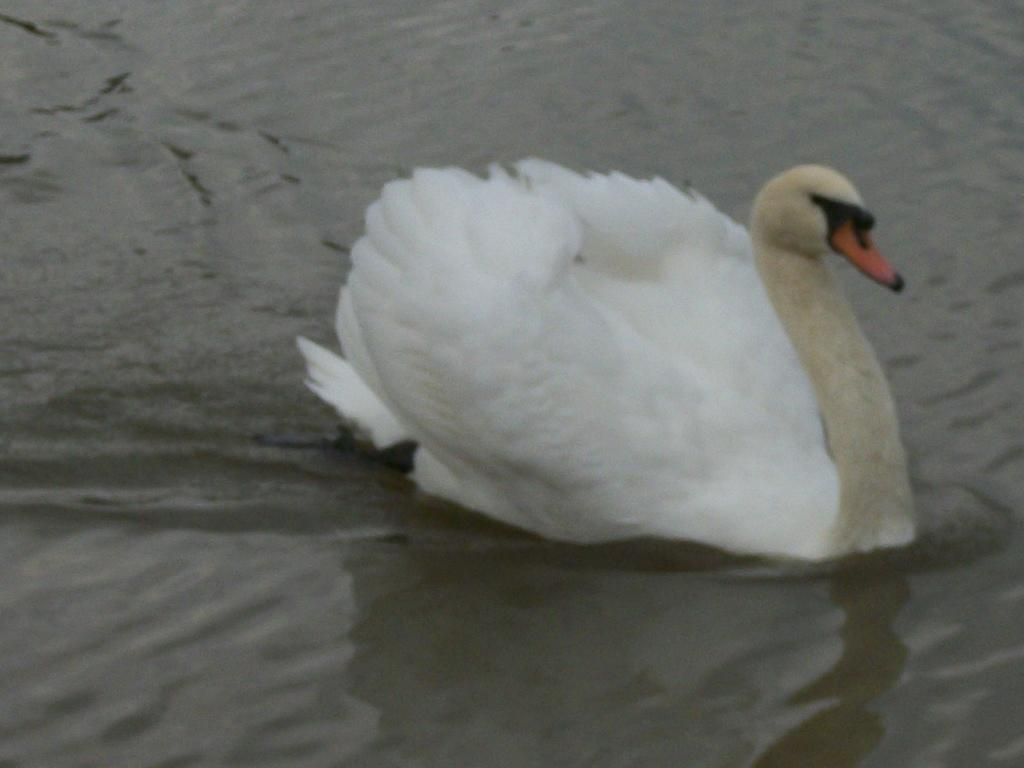What type of animal is in the image? There is a duck in the image. What is the duck doing in the image? The duck is laying on the water. What type of humor can be seen in the image? There is no humor present in the image; it simply features a duck laying on the water. What type of snack is being eaten by the duck in the image? There is no snack, such as popcorn, present in the image. 